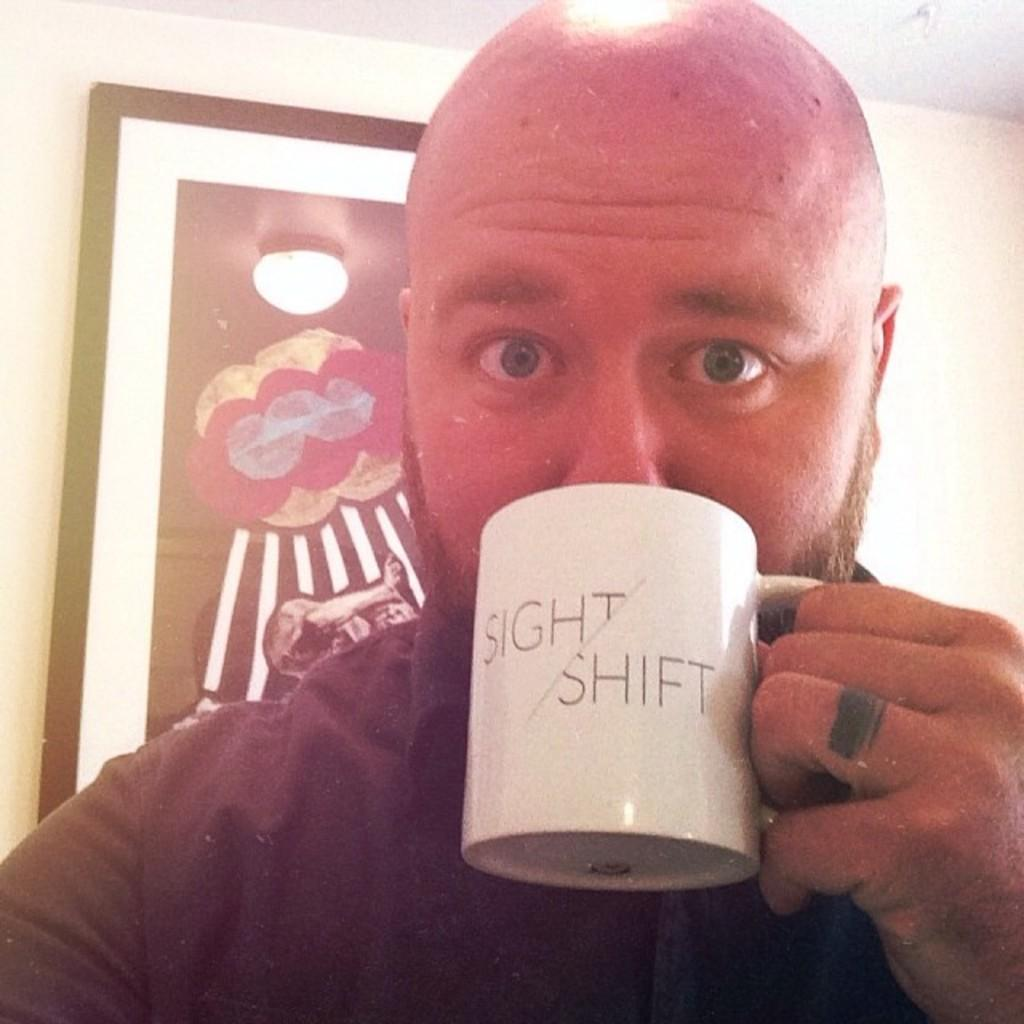<image>
Share a concise interpretation of the image provided. A baldheaded man drinks out of a white mug with a Sight/Shift logo on it. 